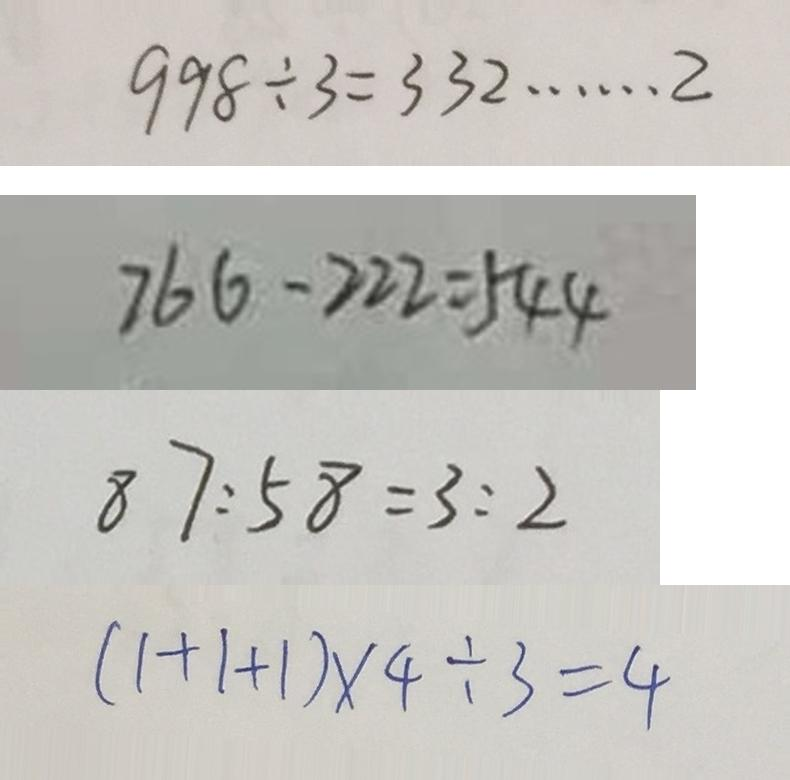Convert formula to latex. <formula><loc_0><loc_0><loc_500><loc_500>9 9 8 \div 3 = 3 3 2 \cdots 2 
 7 6 6 - 2 2 2 = 5 4 4 
 8 7 : 5 8 = 3 : 2 
 ( 1 + 1 + 1 ) \times 4 \div 3 = 4</formula> 